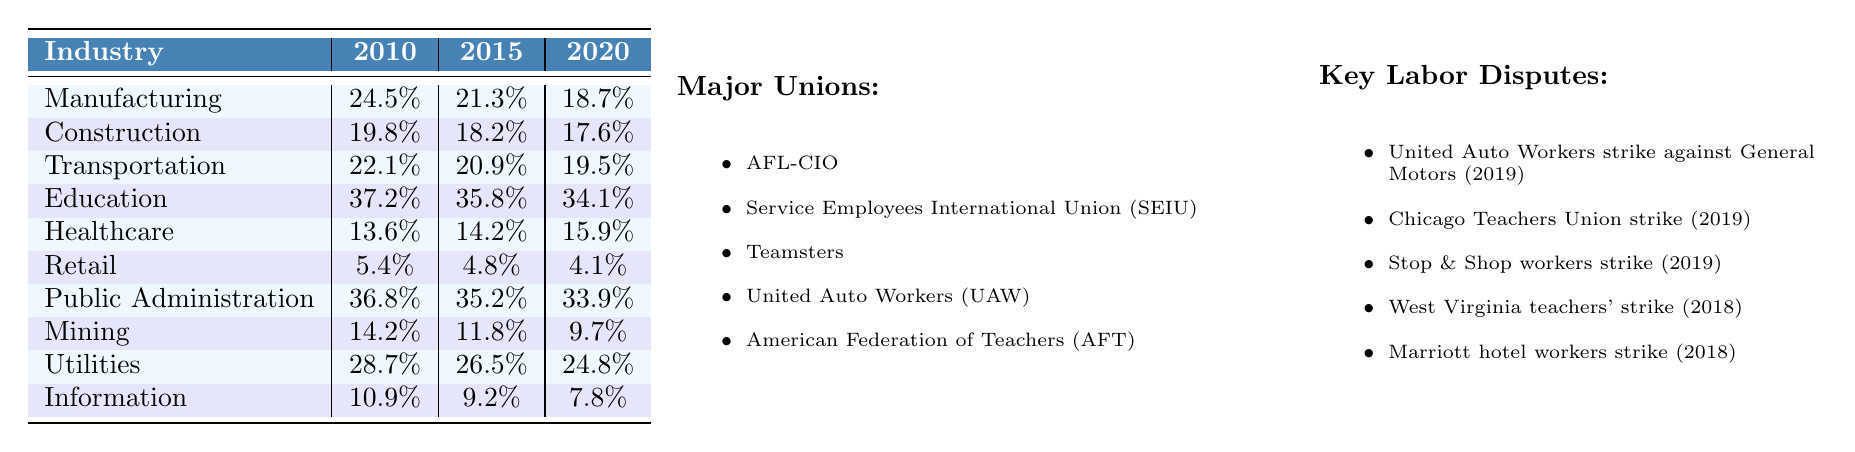What was the union membership rate in the manufacturing industry in 2010? From the table, we can directly see that the union membership rate for manufacturing in 2010 is 24.5%.
Answer: 24.5% Which industry had the highest union membership rate in 2020? By checking the values in the 2020 column, it is evident that education had the highest rate at 34.1%.
Answer: Education What is the difference in union membership rates for healthcare between 2010 and 2020? The healthcare rates for 2010 and 2020 are 13.6% and 15.9%, respectively. To find the difference, we subtract: 15.9% - 13.6% = 2.3%.
Answer: 2.3% What was the average union membership rate for public administration over the years provided? Adding the membership rates for public administration: (36.8% + 35.2% + 33.9%) gives a total of 105.9%. There are three years, so we divide: 105.9% / 3 = 35.3%.
Answer: 35.3% Is the union membership rate for retail higher than that of mining in 2020? In 2020, retail's rate is 4.1%, and mining's rate is 9.7%. Since 4.1% is less than 9.7%, the statement is false.
Answer: No What trend do we observe for the union membership rates in the construction industry from 2010 to 2020? Looking at the rates, they decreased from 19.8% in 2010 to 17.6% in 2020, indicating a downward trend over the years.
Answer: Decreasing trend Which industry experienced the most significant decline in union membership rates from 2010 to 2020? We calculate the decline for each industry: manufacturing from 24.5% to 18.7% (5.8% decline), construction from 19.8% to 17.6% (2.2% decline), transportation from 22.1% to 19.5% (2.6% decline), education from 37.2% to 34.1% (3.1% decline), healthcare from 13.6% to 15.9% (2.3% increase), retail from 5.4% to 4.1% (1.3% decline), public administration from 36.8% to 33.9% (2.9% decline), mining from 14.2% to 9.7% (4.5% decline), utilities from 28.7% to 24.8% (3.9% decline), and information from 10.9% to 7.8% (3.1% decline). The largest decline was in manufacturing with a 5.8% decrease.
Answer: Manufacturing How did the union membership rate change for the information industry from 2010 to 2015? The membership rate for information was 10.9% in 2010 and dropped to 9.2% in 2015. This indicates a decline of 10% in that period.
Answer: Decreased by 1.7% Which industry had the lowest union membership rate in 2015? Checking the 2015 column, retail has the lowest rate at 4.8%.
Answer: Retail 